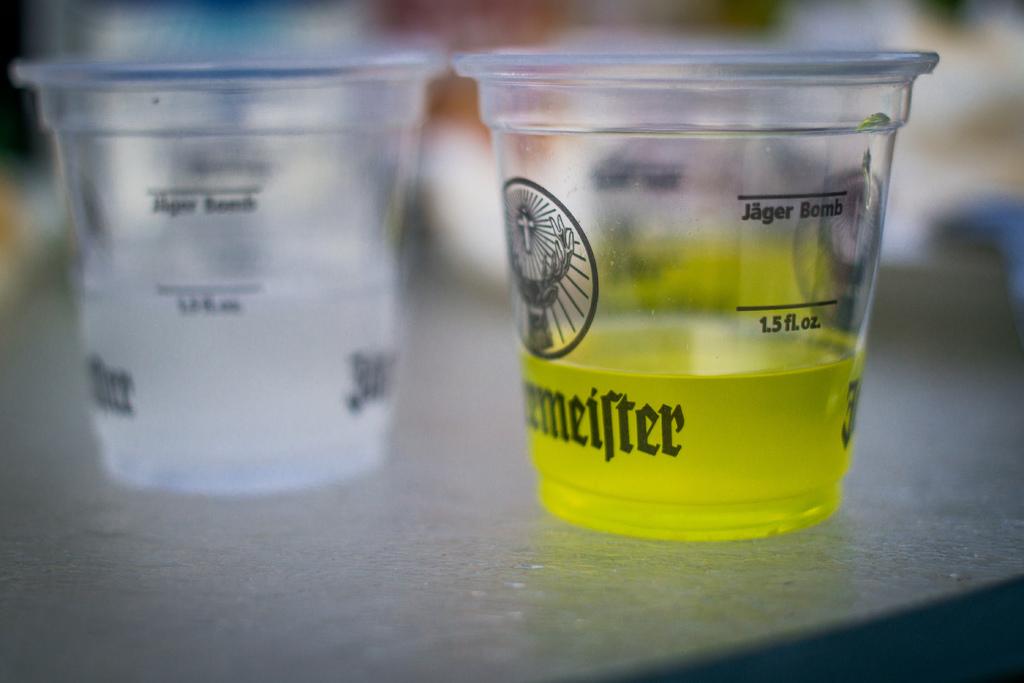What is labelled on the two lines of the cup?
Provide a succinct answer. Jager bomb 1.5 fl. oz. 